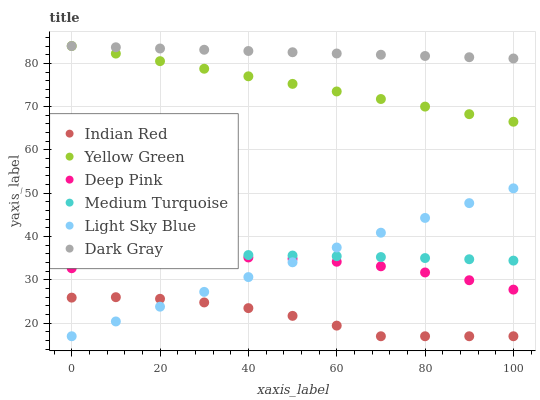Does Indian Red have the minimum area under the curve?
Answer yes or no. Yes. Does Dark Gray have the maximum area under the curve?
Answer yes or no. Yes. Does Yellow Green have the minimum area under the curve?
Answer yes or no. No. Does Yellow Green have the maximum area under the curve?
Answer yes or no. No. Is Light Sky Blue the smoothest?
Answer yes or no. Yes. Is Indian Red the roughest?
Answer yes or no. Yes. Is Yellow Green the smoothest?
Answer yes or no. No. Is Yellow Green the roughest?
Answer yes or no. No. Does Light Sky Blue have the lowest value?
Answer yes or no. Yes. Does Yellow Green have the lowest value?
Answer yes or no. No. Does Dark Gray have the highest value?
Answer yes or no. Yes. Does Light Sky Blue have the highest value?
Answer yes or no. No. Is Deep Pink less than Dark Gray?
Answer yes or no. Yes. Is Dark Gray greater than Deep Pink?
Answer yes or no. Yes. Does Dark Gray intersect Yellow Green?
Answer yes or no. Yes. Is Dark Gray less than Yellow Green?
Answer yes or no. No. Is Dark Gray greater than Yellow Green?
Answer yes or no. No. Does Deep Pink intersect Dark Gray?
Answer yes or no. No. 